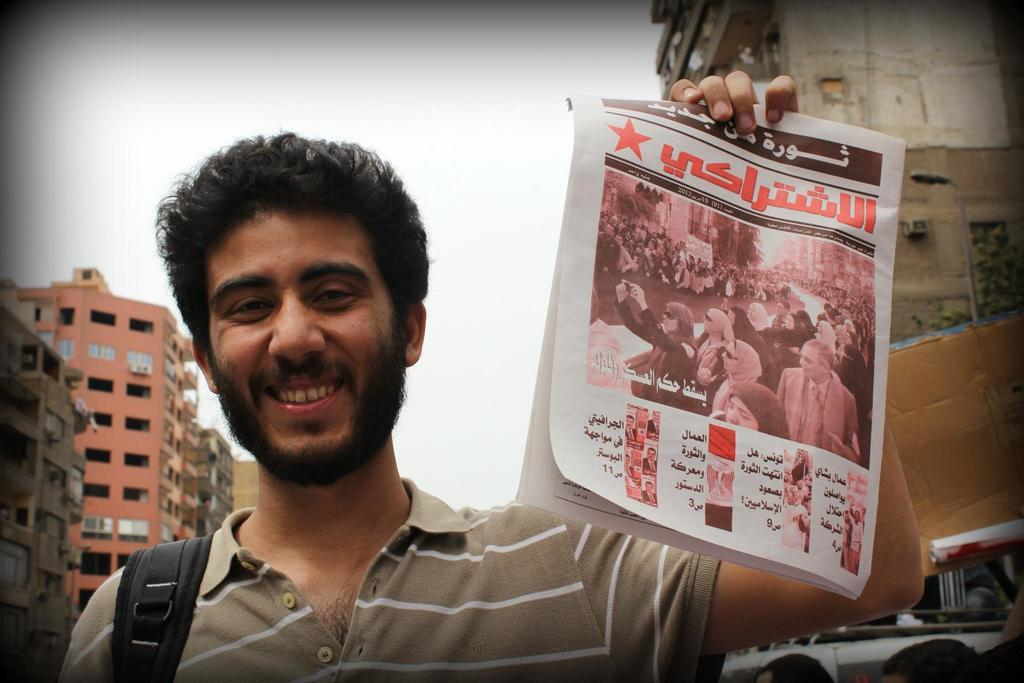Who is the main subject in the image? There is a man in the image. What is the man holding in the image? The man is holding a poster. What can be seen in the background of the image? There are buildings and the sky visible in the background of the image. What type of fowl can be seen in the image? There is no fowl present in the image. What is the condition of the fireman in the image? There is no fireman present in the image. 